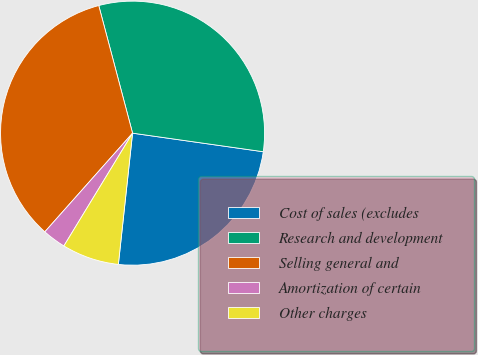Convert chart. <chart><loc_0><loc_0><loc_500><loc_500><pie_chart><fcel>Cost of sales (excludes<fcel>Research and development<fcel>Selling general and<fcel>Amortization of certain<fcel>Other charges<nl><fcel>24.47%<fcel>31.37%<fcel>34.31%<fcel>2.86%<fcel>6.99%<nl></chart> 